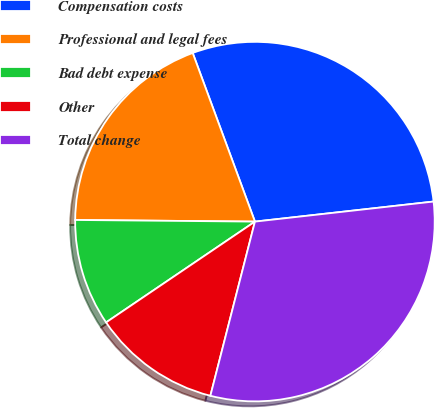<chart> <loc_0><loc_0><loc_500><loc_500><pie_chart><fcel>Compensation costs<fcel>Professional and legal fees<fcel>Bad debt expense<fcel>Other<fcel>Total change<nl><fcel>28.85%<fcel>19.23%<fcel>9.62%<fcel>11.54%<fcel>30.77%<nl></chart> 